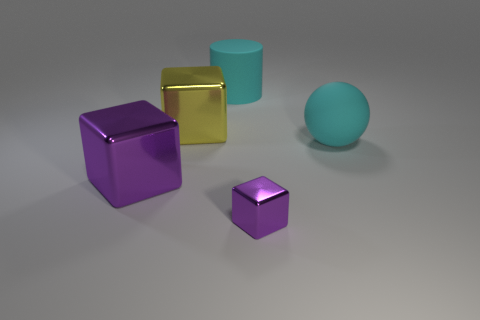Is there a large yellow metallic thing?
Make the answer very short. Yes. How many other objects are there of the same size as the cyan matte cylinder?
Your answer should be very brief. 3. Do the tiny purple object and the large object in front of the large cyan rubber ball have the same material?
Offer a terse response. Yes. Are there the same number of purple metallic cubes that are left of the large matte sphere and cubes that are behind the tiny thing?
Provide a short and direct response. Yes. What is the tiny block made of?
Ensure brevity in your answer.  Metal. What color is the ball that is the same size as the cyan cylinder?
Provide a short and direct response. Cyan. Are there any cyan cylinders that are behind the shiny cube that is right of the cyan cylinder?
Keep it short and to the point. Yes. How many spheres are cyan rubber things or large objects?
Ensure brevity in your answer.  1. There is a cyan object left of the rubber object that is in front of the large metal object to the right of the large purple shiny object; how big is it?
Offer a very short reply. Large. There is a large purple metallic object; are there any small purple objects in front of it?
Keep it short and to the point. Yes. 